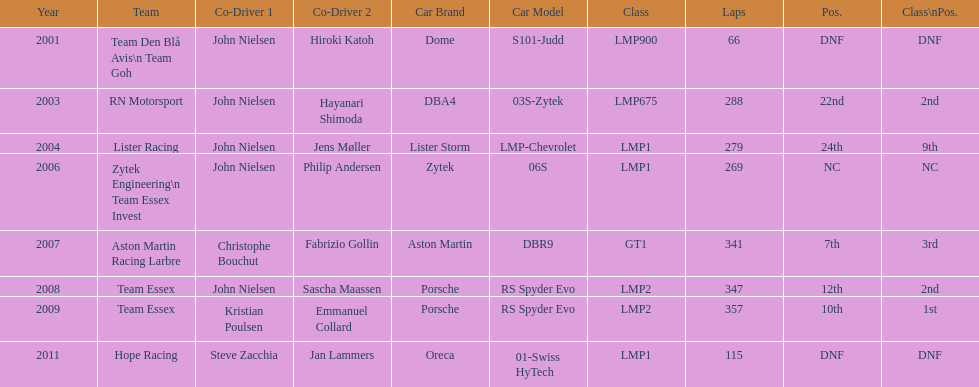Who was john nielsen co-driver for team lister in 2004? Jens Møller. 